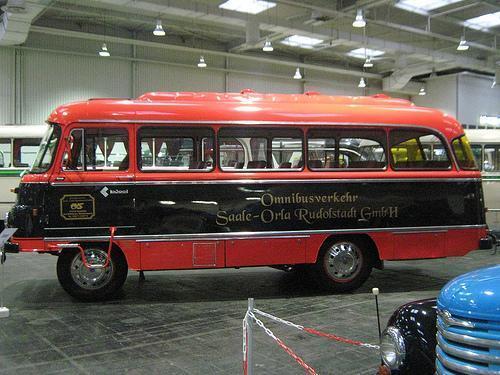How many red bus parked?
Give a very brief answer. 1. 